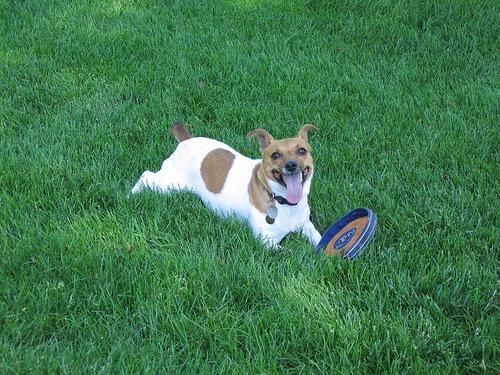What is the dog playing with?
Short answer required. Frisbee. Are there people playing on the grass?
Short answer required. No. What type of dog is this?
Be succinct. Terrier. Is this dog happy?
Short answer required. Yes. What color is the dog?
Keep it brief. Brown and white. What color is the disk?
Be succinct. Blue. 